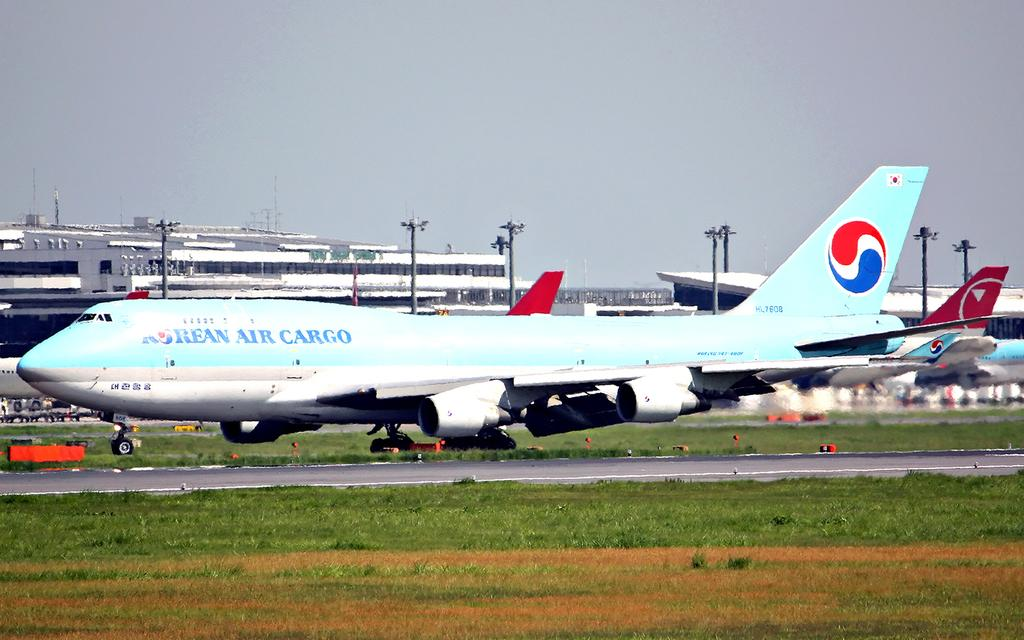<image>
Present a compact description of the photo's key features. A Korean Air Cargo plane on the grass beside a runway. 